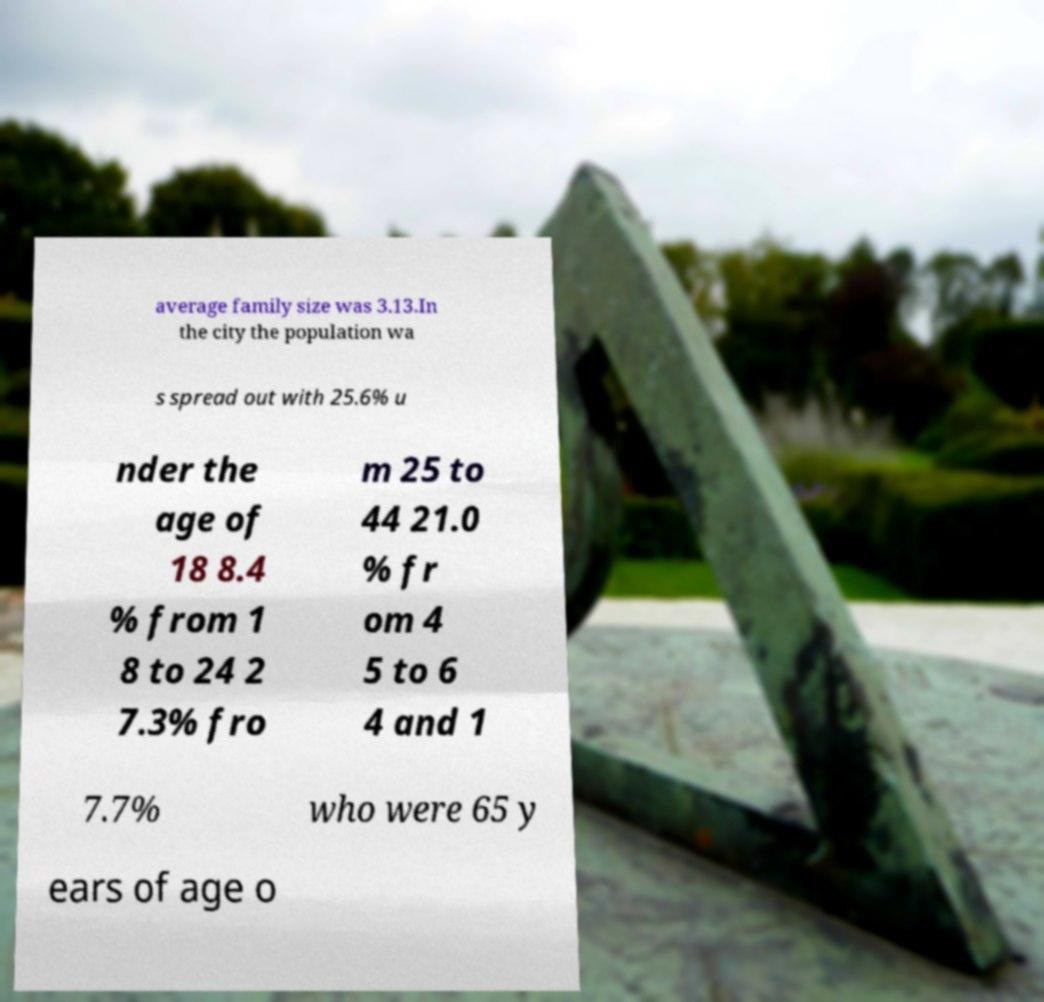Could you assist in decoding the text presented in this image and type it out clearly? average family size was 3.13.In the city the population wa s spread out with 25.6% u nder the age of 18 8.4 % from 1 8 to 24 2 7.3% fro m 25 to 44 21.0 % fr om 4 5 to 6 4 and 1 7.7% who were 65 y ears of age o 